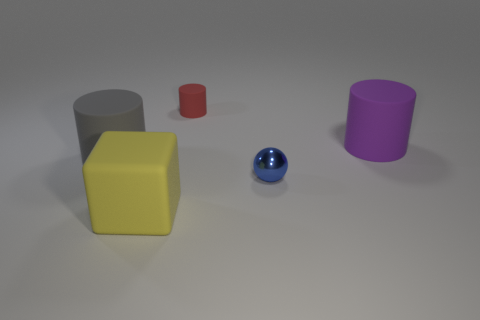Are there any other things that have the same material as the blue object?
Your answer should be compact. No. What number of brown objects are either large cubes or cylinders?
Your answer should be compact. 0. There is a large object that is in front of the tiny blue object; how many yellow things are right of it?
Ensure brevity in your answer.  0. Are there more objects that are to the left of the small blue metal sphere than gray cylinders that are to the left of the big gray cylinder?
Your response must be concise. Yes. What is the material of the cube?
Provide a succinct answer. Rubber. Is there a metal ball that has the same size as the red rubber thing?
Give a very brief answer. Yes. What material is the blue ball that is the same size as the red object?
Your response must be concise. Metal. How many brown matte things are there?
Ensure brevity in your answer.  0. There is a red matte thing that is behind the small blue metallic thing; what size is it?
Keep it short and to the point. Small. Are there an equal number of small blue metallic balls that are in front of the purple cylinder and small blue things?
Your answer should be compact. Yes. 